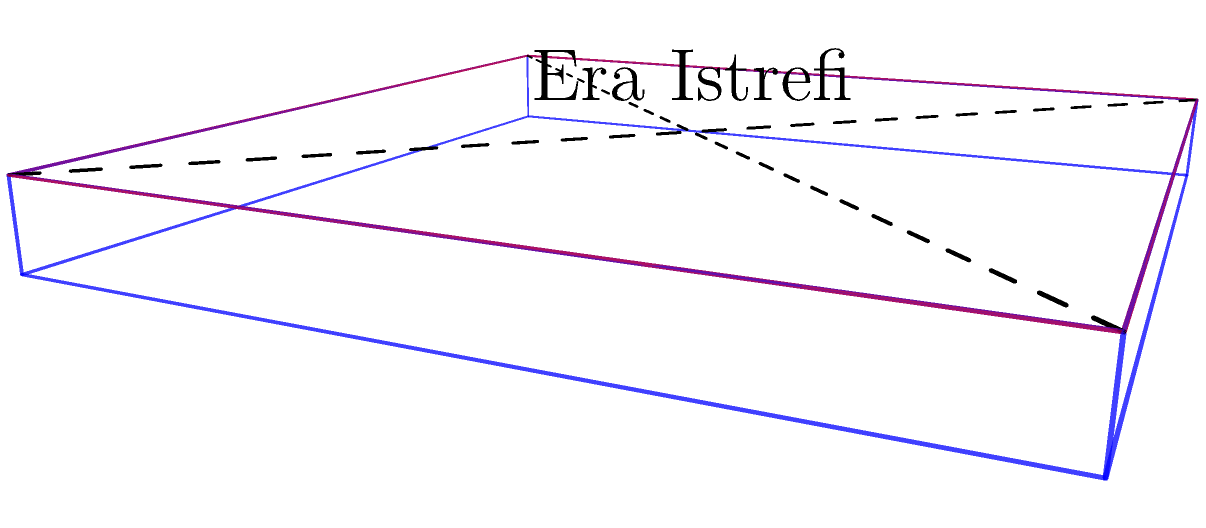Era Istrefi's latest album cover is a square design that needs to be folded into a CD case. The cover has diagonal fold lines from corner to corner. If you mentally fold the square along these diagonals, which shape will the folded cover form when placed inside the CD case? To solve this problem, let's follow these steps:

1. Visualize the square album cover with diagonal fold lines.
2. Mentally fold the cover along these diagonals:
   a. The top-left corner will fold towards the center.
   b. The top-right corner will fold towards the center.
   c. The bottom-left corner will fold towards the center.
   d. The bottom-right corner will fold towards the center.
3. As all four corners fold inward, they will meet at the center point.
4. The resulting shape will have four triangular faces, each representing a quarter of the original square.
5. When placed inside the CD case, this folded shape will form a three-dimensional structure.
6. The structure created by this folding pattern is a pyramid with a square base.

Therefore, when the square album cover is folded along its diagonals and placed inside the CD case, it will form a pyramid shape.
Answer: Pyramid 